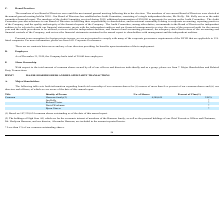According to Nordic American Tankers Limited's financial document, How many common shares were outstanding as of the date of this annual report? According to the financial document, 147,230,634. The relevant text states: "(1) Based on 147,230,634 common shares outstanding as of the date of this annual report...." Also, How many shares are owned by the Hansson family? According to the financial document, 4,380,659. The relevant text states: "Common Hansson family(2) 4,380,659 2.98%..." Also, What is the percentage of shares owned by the Hanssen family? According to the financial document, 2.98%. The relevant text states: "Common Hansson family(2) 4,380,659 2.98%..." Also, can you calculate: What is the total number of shares owned by the Hanssen family and Richard Vietor? Based on the calculation: (4,380,659 + 0) , the result is 4380659. This is based on the information: "Common Hansson family(2) 4,380,659 2.98% Common Hansson family(2) 4,380,659 2.98%..." The key data points involved are: 4,380,659. Also, can you calculate: What is the average number of shares owned by the Hanssen family and Jim Kelly? To answer this question, I need to perform calculations using the financial data. The calculation is: (4,380,659 + 0)/2 , which equals 2190329.5. This is based on the information: "Common Hansson family(2) 4,380,659 2.98% Common Hansson family(2) 4,380,659 2.98%..." The key data points involved are: 4,380,659. Also, can you calculate: What is the total number of shares owned by David Workman and Bjørn Giæver? I cannot find a specific answer to this question in the financial document. 